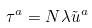Convert formula to latex. <formula><loc_0><loc_0><loc_500><loc_500>\tau ^ { a } = N \lambda \tilde { u } ^ { a }</formula> 